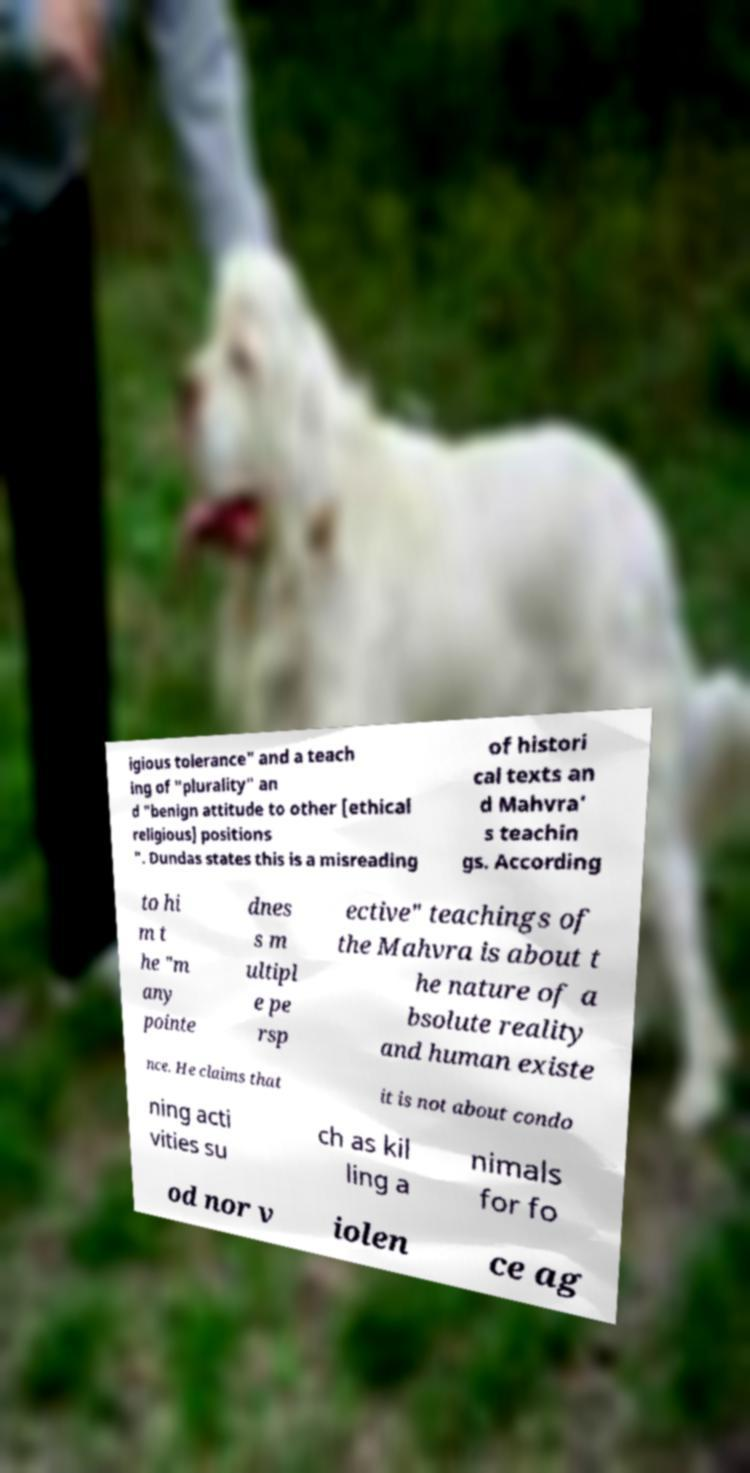For documentation purposes, I need the text within this image transcribed. Could you provide that? igious tolerance" and a teach ing of "plurality" an d "benign attitude to other [ethical religious] positions ". Dundas states this is a misreading of histori cal texts an d Mahvra' s teachin gs. According to hi m t he "m any pointe dnes s m ultipl e pe rsp ective" teachings of the Mahvra is about t he nature of a bsolute reality and human existe nce. He claims that it is not about condo ning acti vities su ch as kil ling a nimals for fo od nor v iolen ce ag 